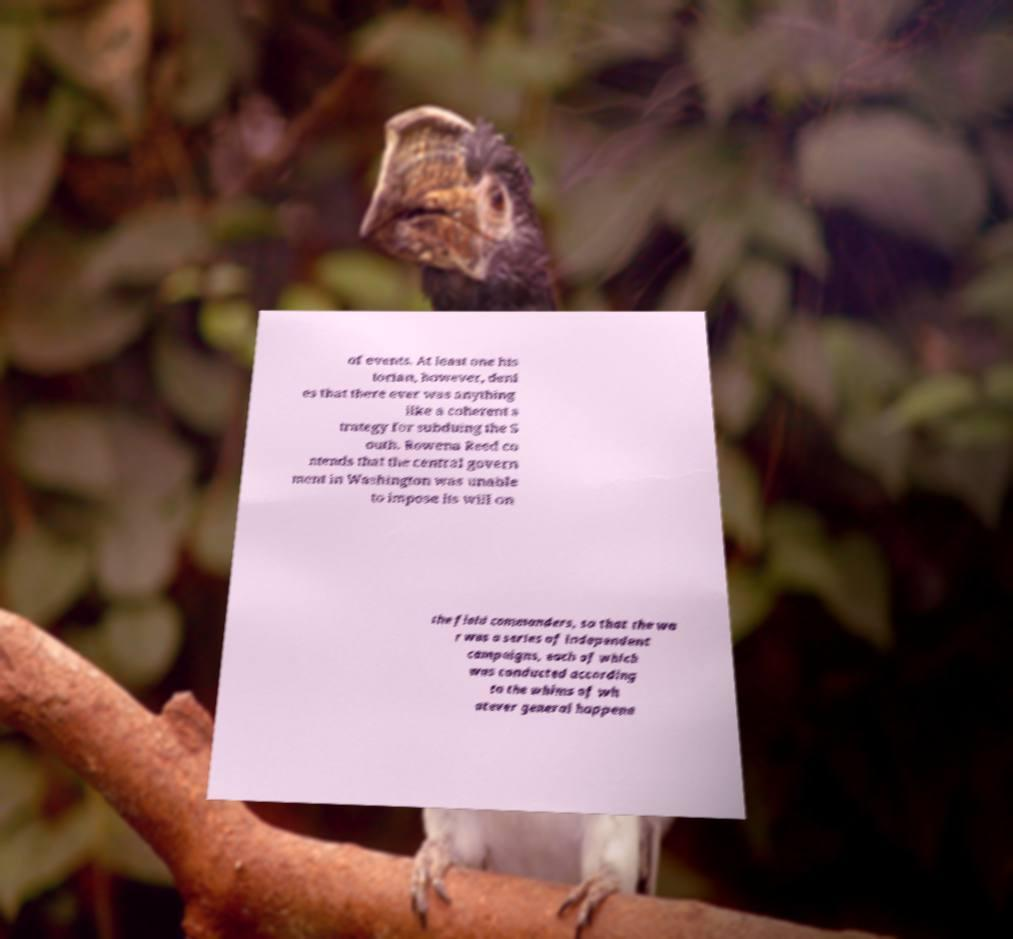There's text embedded in this image that I need extracted. Can you transcribe it verbatim? of events. At least one his torian, however, deni es that there ever was anything like a coherent s trategy for subduing the S outh. Rowena Reed co ntends that the central govern ment in Washington was unable to impose its will on the field commanders, so that the wa r was a series of independent campaigns, each of which was conducted according to the whims of wh atever general happene 